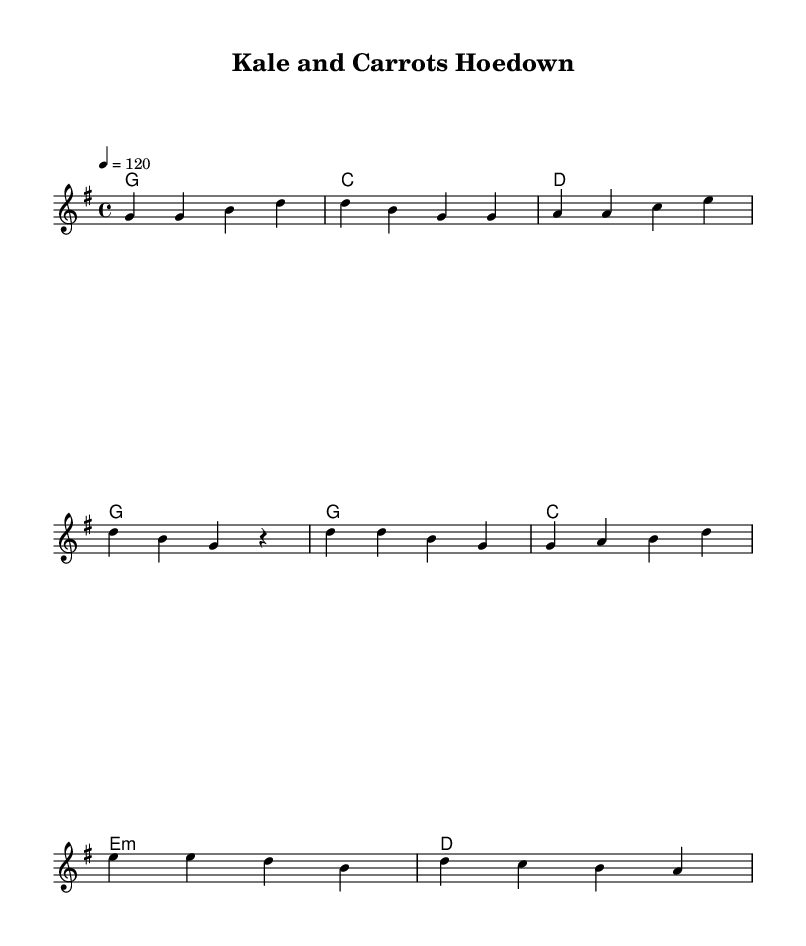What is the key signature of this music? The key signature is G major, which has one sharp (F#). This is determined by identifying the sharp symbols in the key signature in the music sheet.
Answer: G major What is the time signature of this music? The time signature is 4/4, which means there are four beats in each measure and the quarter note receives one beat. This is indicated at the beginning of the score.
Answer: 4/4 What is the tempo marking for this piece? The tempo marking is 120 beats per minute. This is found in the tempo notation at the beginning of the sheet music, indicating the speed of the piece.
Answer: 120 How many measures are there in the verse? There are four measures in the verse, as counted from the beginning of the sheet music until the end of the verse section, marked by the separation from the chorus.
Answer: 4 What is the first chord of the chorus? The first chord of the chorus is G major, which is specified at the beginning of the chorus section in the chord line of the sheet music.
Answer: G What is the main theme of the lyrics in this song? The main theme of the lyrics celebrates farm-fresh vegetables and their health benefits. This can be inferred by reading the lyrics provided, focusing on the words and their context.
Answer: Farm-fresh vegetables How many verses are there in this song? There is one verse in the song, as indicated prior to the chorus without repetition within the provided music notation.
Answer: 1 